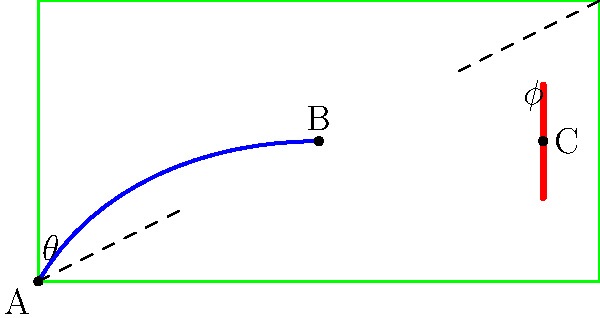In the diagram representing a free kick trajectory in a JCB Bhilai Brothers FC match, the path of the ball is shown from point A to point C, passing through point B. If the initial angle of the kick at point A is $\theta$ and the final angle of approach to the goal at point C is $\phi$, what is the relationship between these angles that best describes the curvature of the ball's path? To understand the relationship between the angles $\theta$ and $\phi$ in the context of the ball's curved trajectory, let's follow these steps:

1. Observe that the ball's path starts at point A (where the kick is taken) and ends at point C (the goal), passing through point B (the apex of the curve).

2. The initial angle $\theta$ represents the angle at which the ball is kicked, measured from the horizontal.

3. The final angle $\phi$ represents the angle at which the ball approaches the goal, also measured from the horizontal.

4. In a straight-line trajectory, these angles would be equal ($\theta = \phi$).

5. However, due to the curvature of the ball's path:
   a) The ball initially rises at angle $\theta$.
   b) It reaches its highest point at B.
   c) It then descends towards the goal at angle $\phi$.

6. The curvature of the path is caused by factors such as the spin imparted on the ball and air resistance.

7. For a typical curved free kick, the ball's path will bend downwards as it travels, meaning the final approach angle will be steeper than the initial kick angle.

8. Therefore, in most cases of a curving free kick, the relationship between these angles will be: $\phi > \theta$.

This relationship ($\phi > \theta$) indicates that the ball is following a curved path that bends downwards, which is characteristic of many successful free kicks in football.
Answer: $\phi > \theta$ 